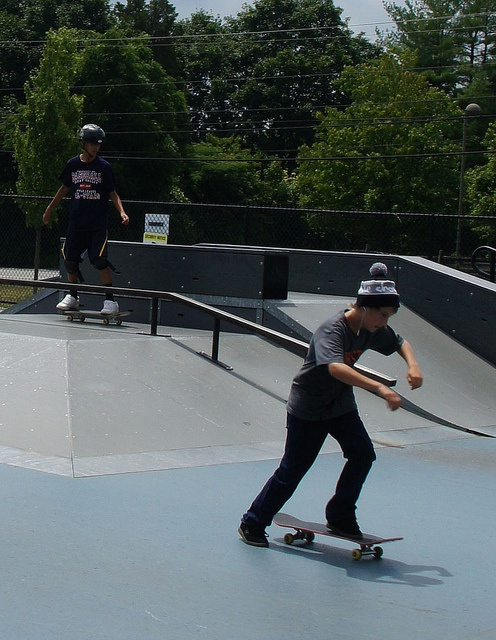Describe the objects in this image and their specific colors. I can see people in black, gray, darkgray, and maroon tones, people in black, gray, darkgray, and maroon tones, skateboard in black, gray, darkgray, and maroon tones, and skateboard in black and gray tones in this image. 